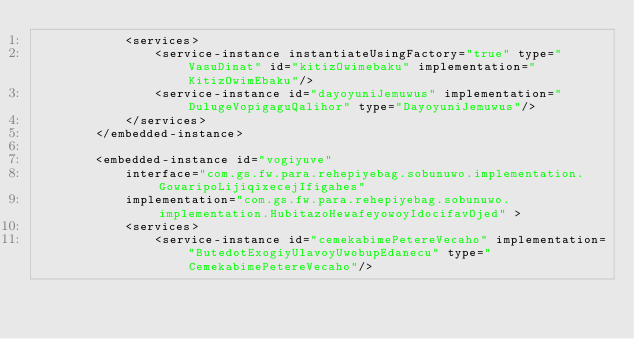Convert code to text. <code><loc_0><loc_0><loc_500><loc_500><_XML_>            <services>
                <service-instance instantiateUsingFactory="true" type="VasuDinat" id="kitizOwimebaku" implementation="KitizOwimEbaku"/>
                <service-instance id="dayoyuniJemuwus" implementation="DulugeVopigaguQalihor" type="DayoyuniJemuwus"/>
            </services>
        </embedded-instance>

        <embedded-instance id="vogiyuve"
            interface="com.gs.fw.para.rehepiyebag.sobunuwo.implementation.GowaripoLijiqixecejIfigahes"
            implementation="com.gs.fw.para.rehepiyebag.sobunuwo.implementation.HubitazoHewafeyowoyIdocifavOjed" >
            <services>
                <service-instance id="cemekabimePetereVecaho" implementation="ButedotExogiyUlavoyUwobupEdanecu" type="CemekabimePetereVecaho"/></code> 